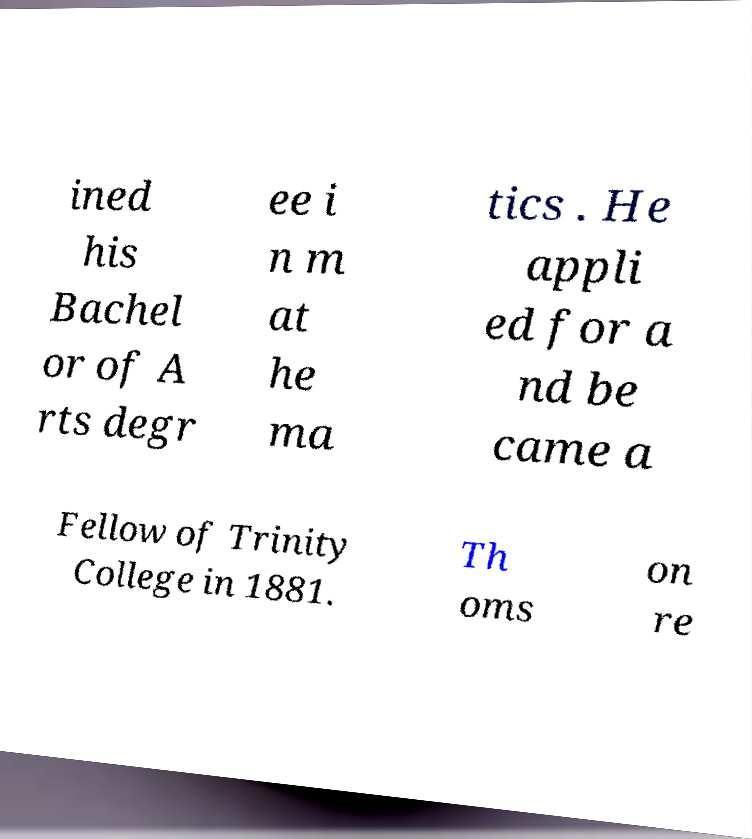Please identify and transcribe the text found in this image. ined his Bachel or of A rts degr ee i n m at he ma tics . He appli ed for a nd be came a Fellow of Trinity College in 1881. Th oms on re 